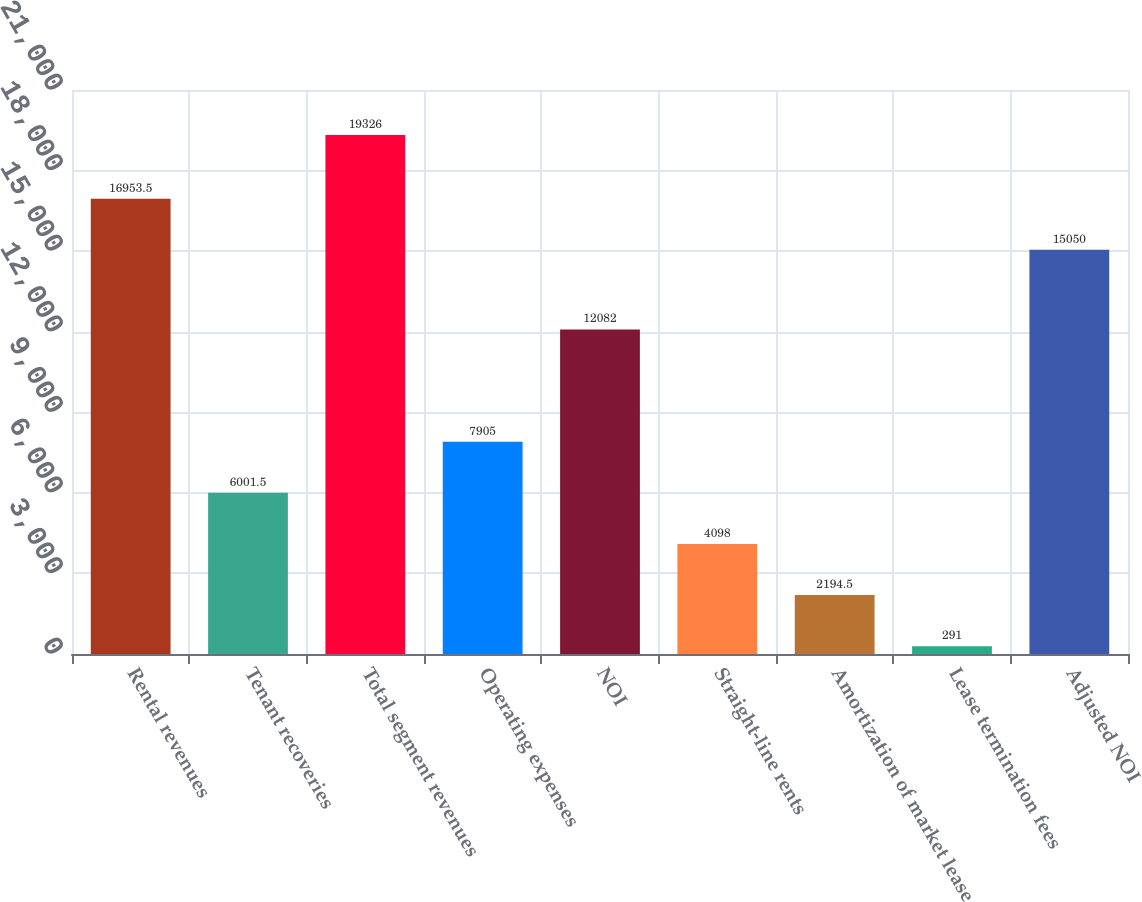<chart> <loc_0><loc_0><loc_500><loc_500><bar_chart><fcel>Rental revenues<fcel>Tenant recoveries<fcel>Total segment revenues<fcel>Operating expenses<fcel>NOI<fcel>Straight-line rents<fcel>Amortization of market lease<fcel>Lease termination fees<fcel>Adjusted NOI<nl><fcel>16953.5<fcel>6001.5<fcel>19326<fcel>7905<fcel>12082<fcel>4098<fcel>2194.5<fcel>291<fcel>15050<nl></chart> 